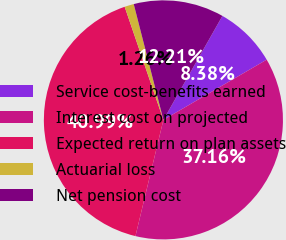Convert chart to OTSL. <chart><loc_0><loc_0><loc_500><loc_500><pie_chart><fcel>Service cost-benefits earned<fcel>Interest cost on projected<fcel>Expected return on plan assets<fcel>Actuarial loss<fcel>Net pension cost<nl><fcel>8.38%<fcel>37.16%<fcel>40.99%<fcel>1.26%<fcel>12.21%<nl></chart> 